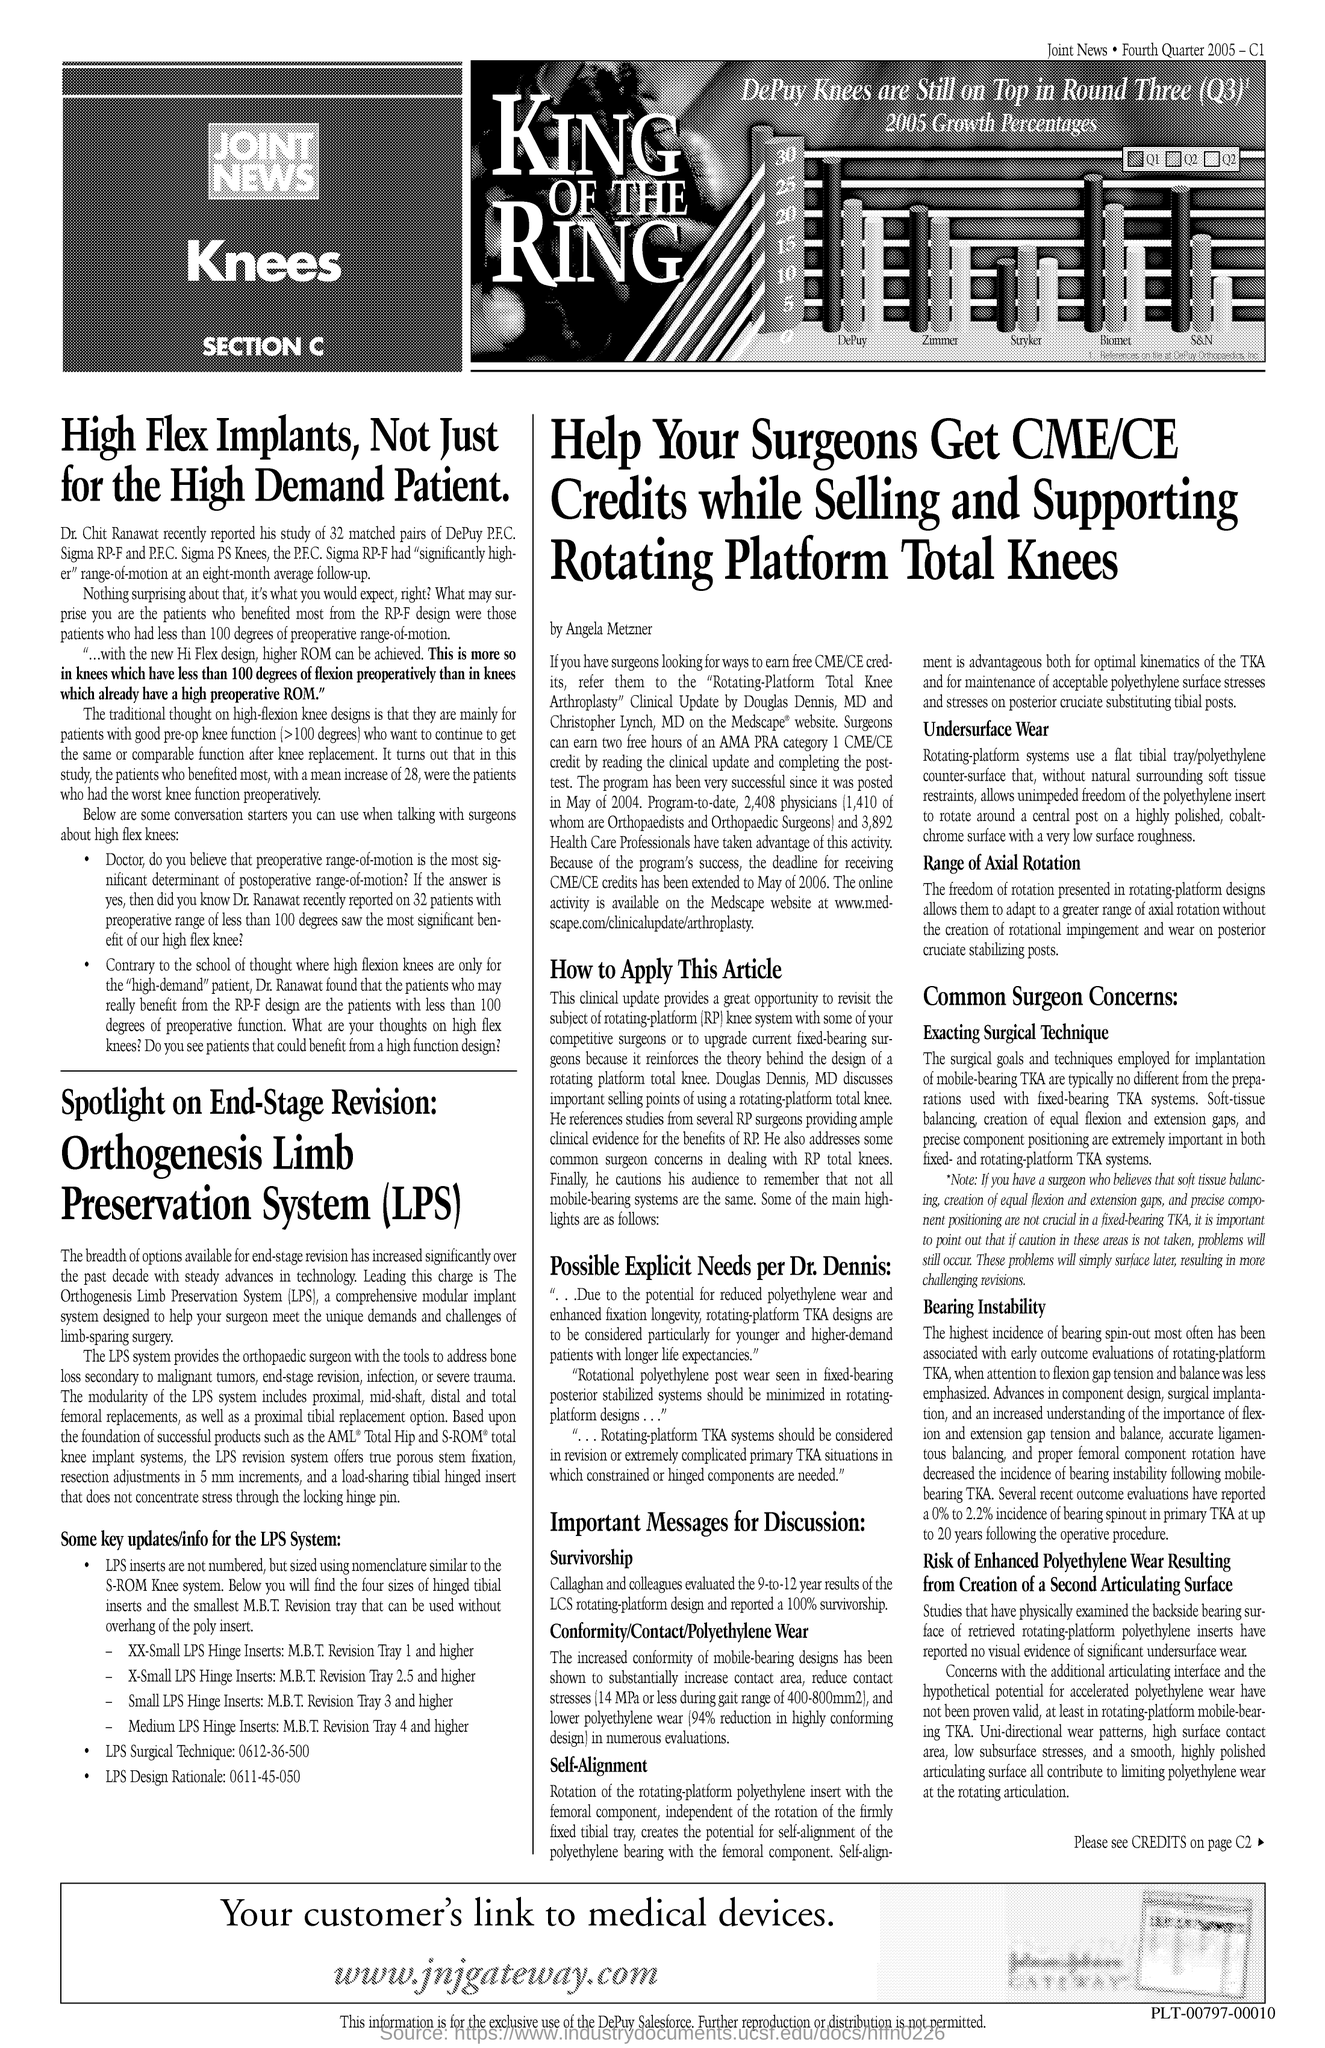Specify some key components in this picture. The URL mentioned in the document is [www.jnjgateway.com](http://www.jnjgateway.com). 